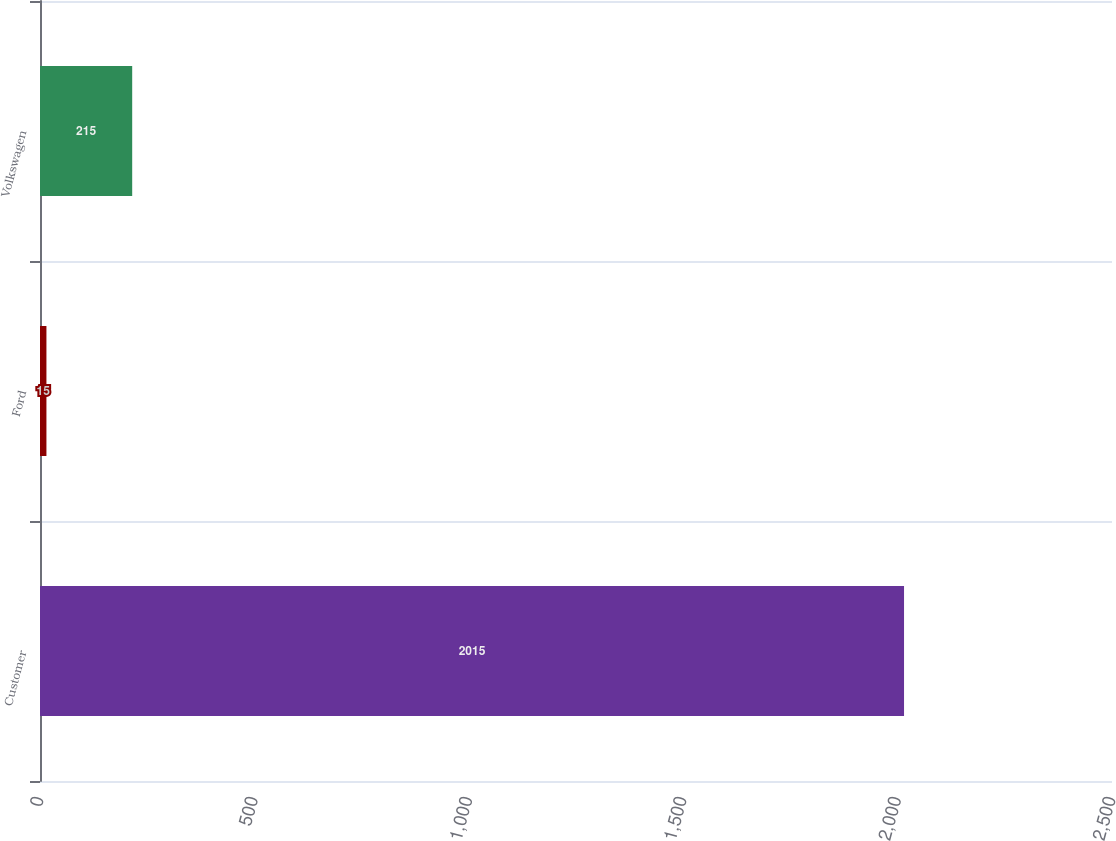<chart> <loc_0><loc_0><loc_500><loc_500><bar_chart><fcel>Customer<fcel>Ford<fcel>Volkswagen<nl><fcel>2015<fcel>15<fcel>215<nl></chart> 